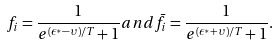<formula> <loc_0><loc_0><loc_500><loc_500>f _ { i } = \frac { 1 } { e ^ { ( \epsilon ^ { * } - \upsilon ) / T } + 1 } a n d \bar { f } _ { i } = \frac { 1 } { e ^ { ( \epsilon ^ { * } + \upsilon ) / T } + 1 } .</formula> 